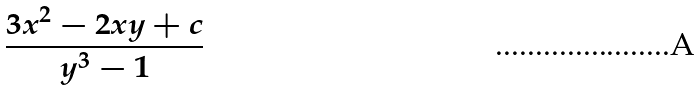Convert formula to latex. <formula><loc_0><loc_0><loc_500><loc_500>\frac { 3 x ^ { 2 } - 2 x y + c } { y ^ { 3 } - 1 }</formula> 